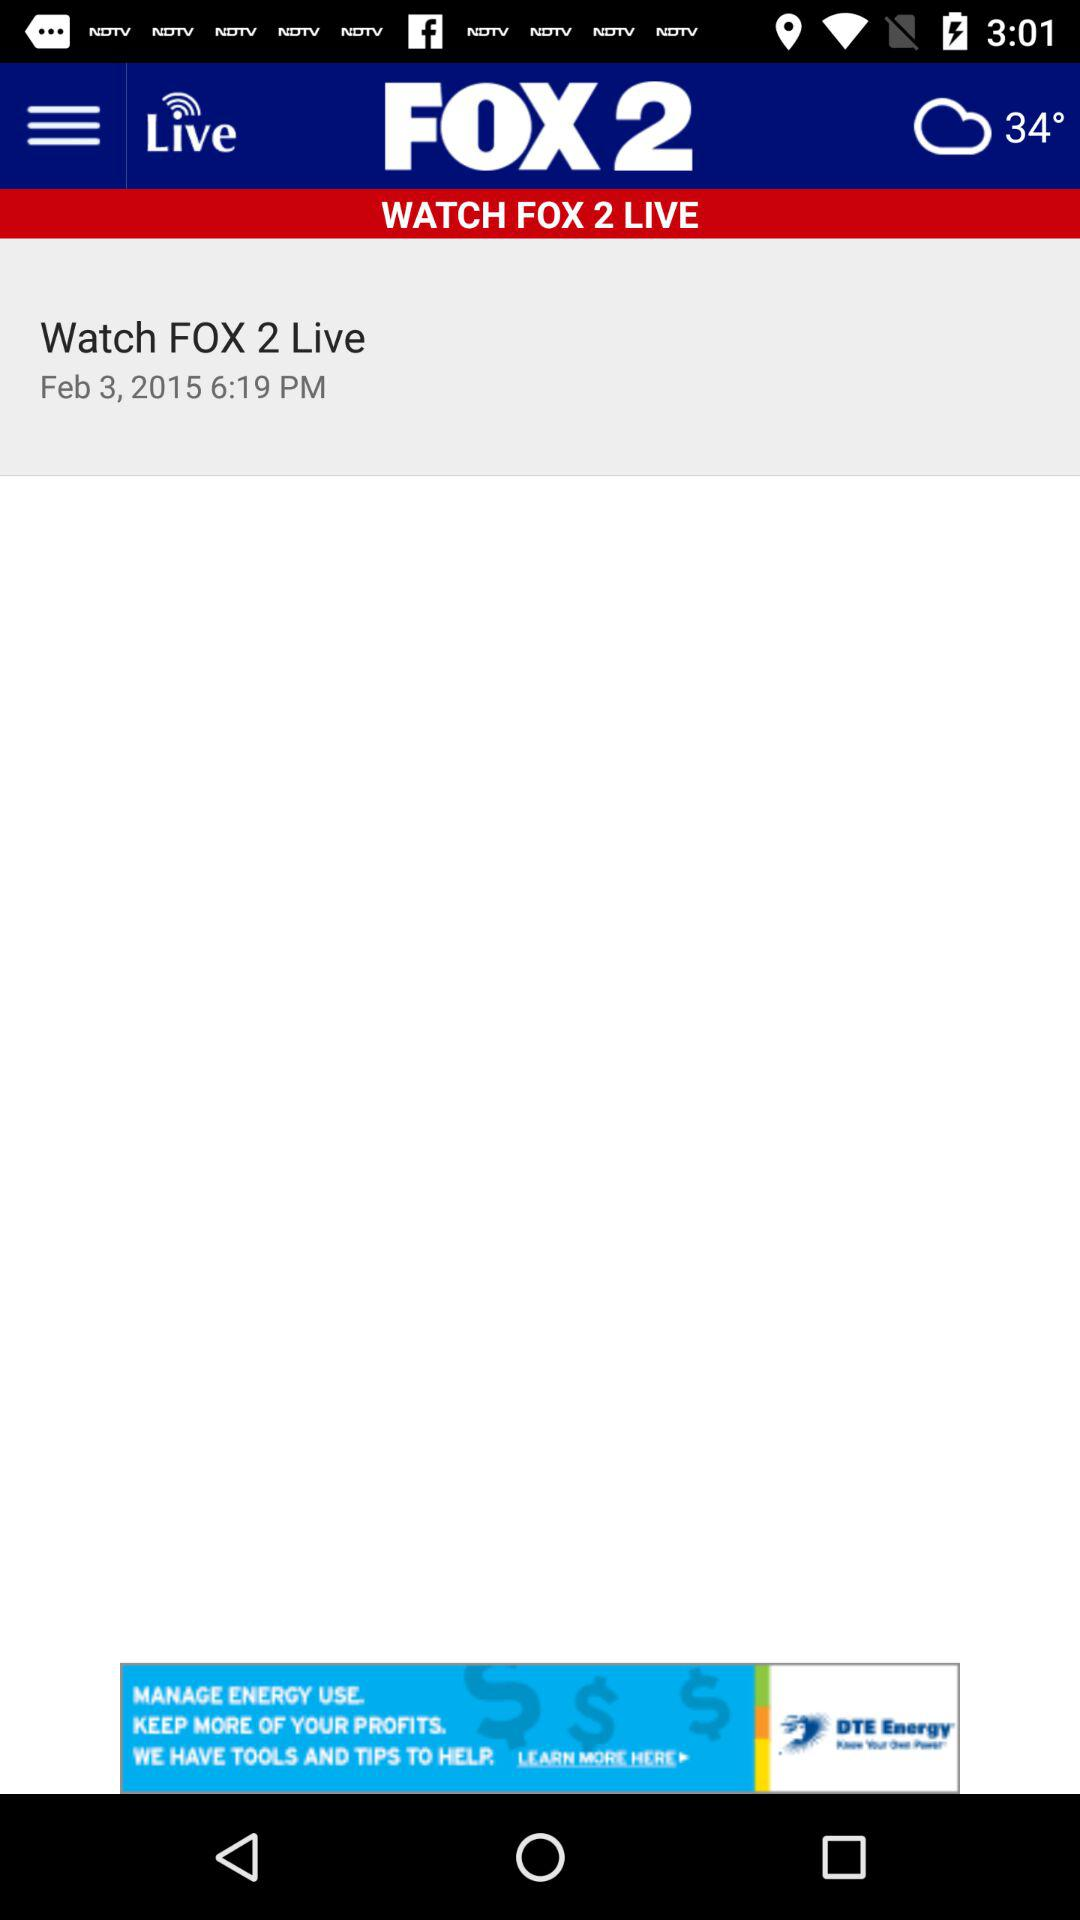At what date will "FOX 2 Live" start? "FOX 2 Live" will start on February 3, 2015. 